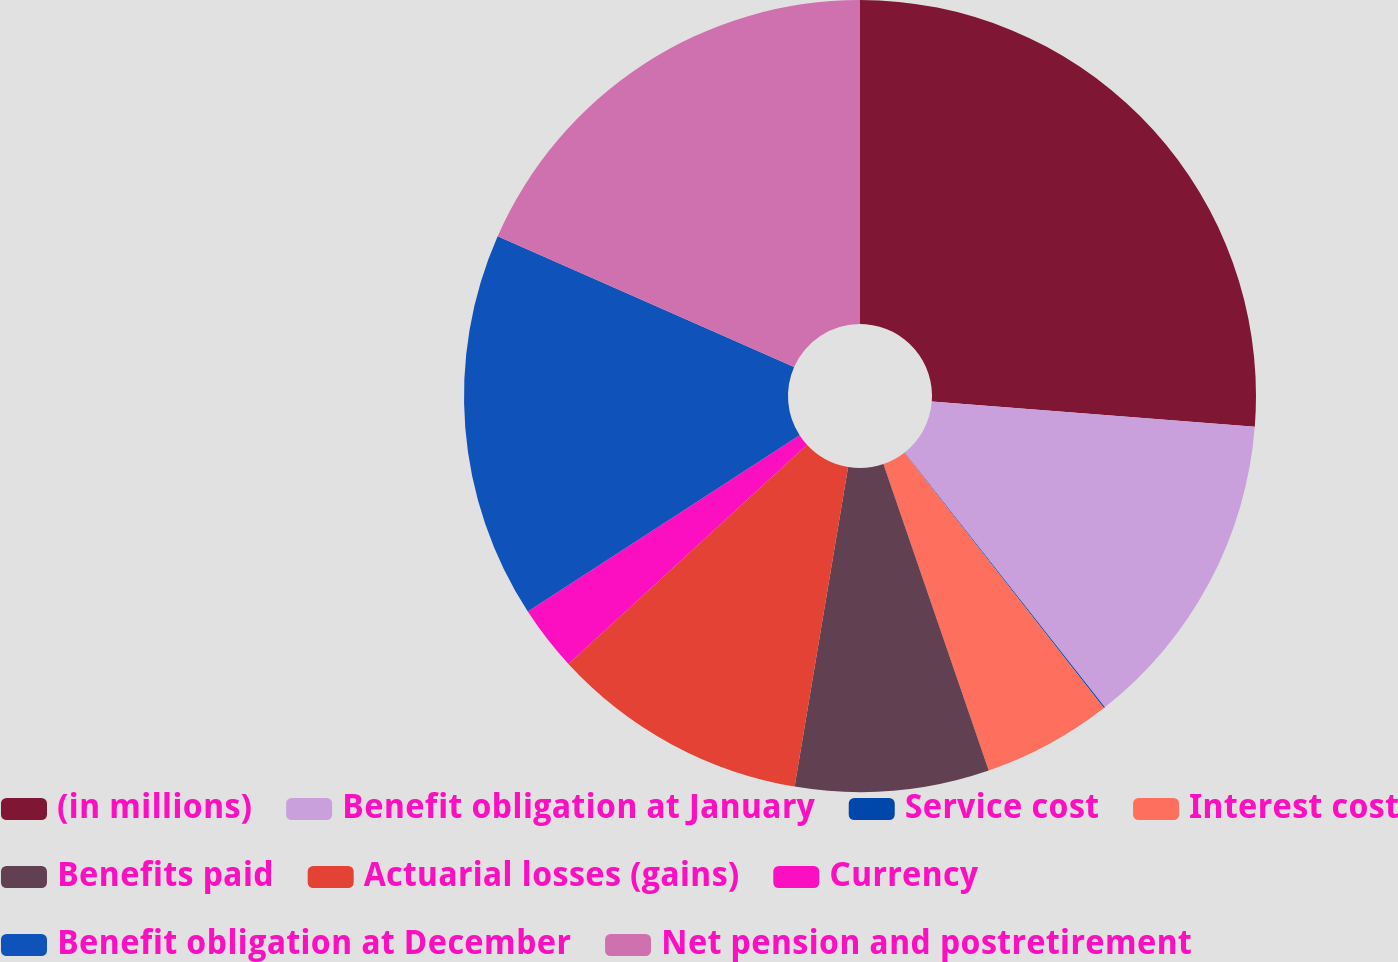<chart> <loc_0><loc_0><loc_500><loc_500><pie_chart><fcel>(in millions)<fcel>Benefit obligation at January<fcel>Service cost<fcel>Interest cost<fcel>Benefits paid<fcel>Actuarial losses (gains)<fcel>Currency<fcel>Benefit obligation at December<fcel>Net pension and postretirement<nl><fcel>26.24%<fcel>13.15%<fcel>0.05%<fcel>5.29%<fcel>7.91%<fcel>10.53%<fcel>2.67%<fcel>15.77%<fcel>18.39%<nl></chart> 